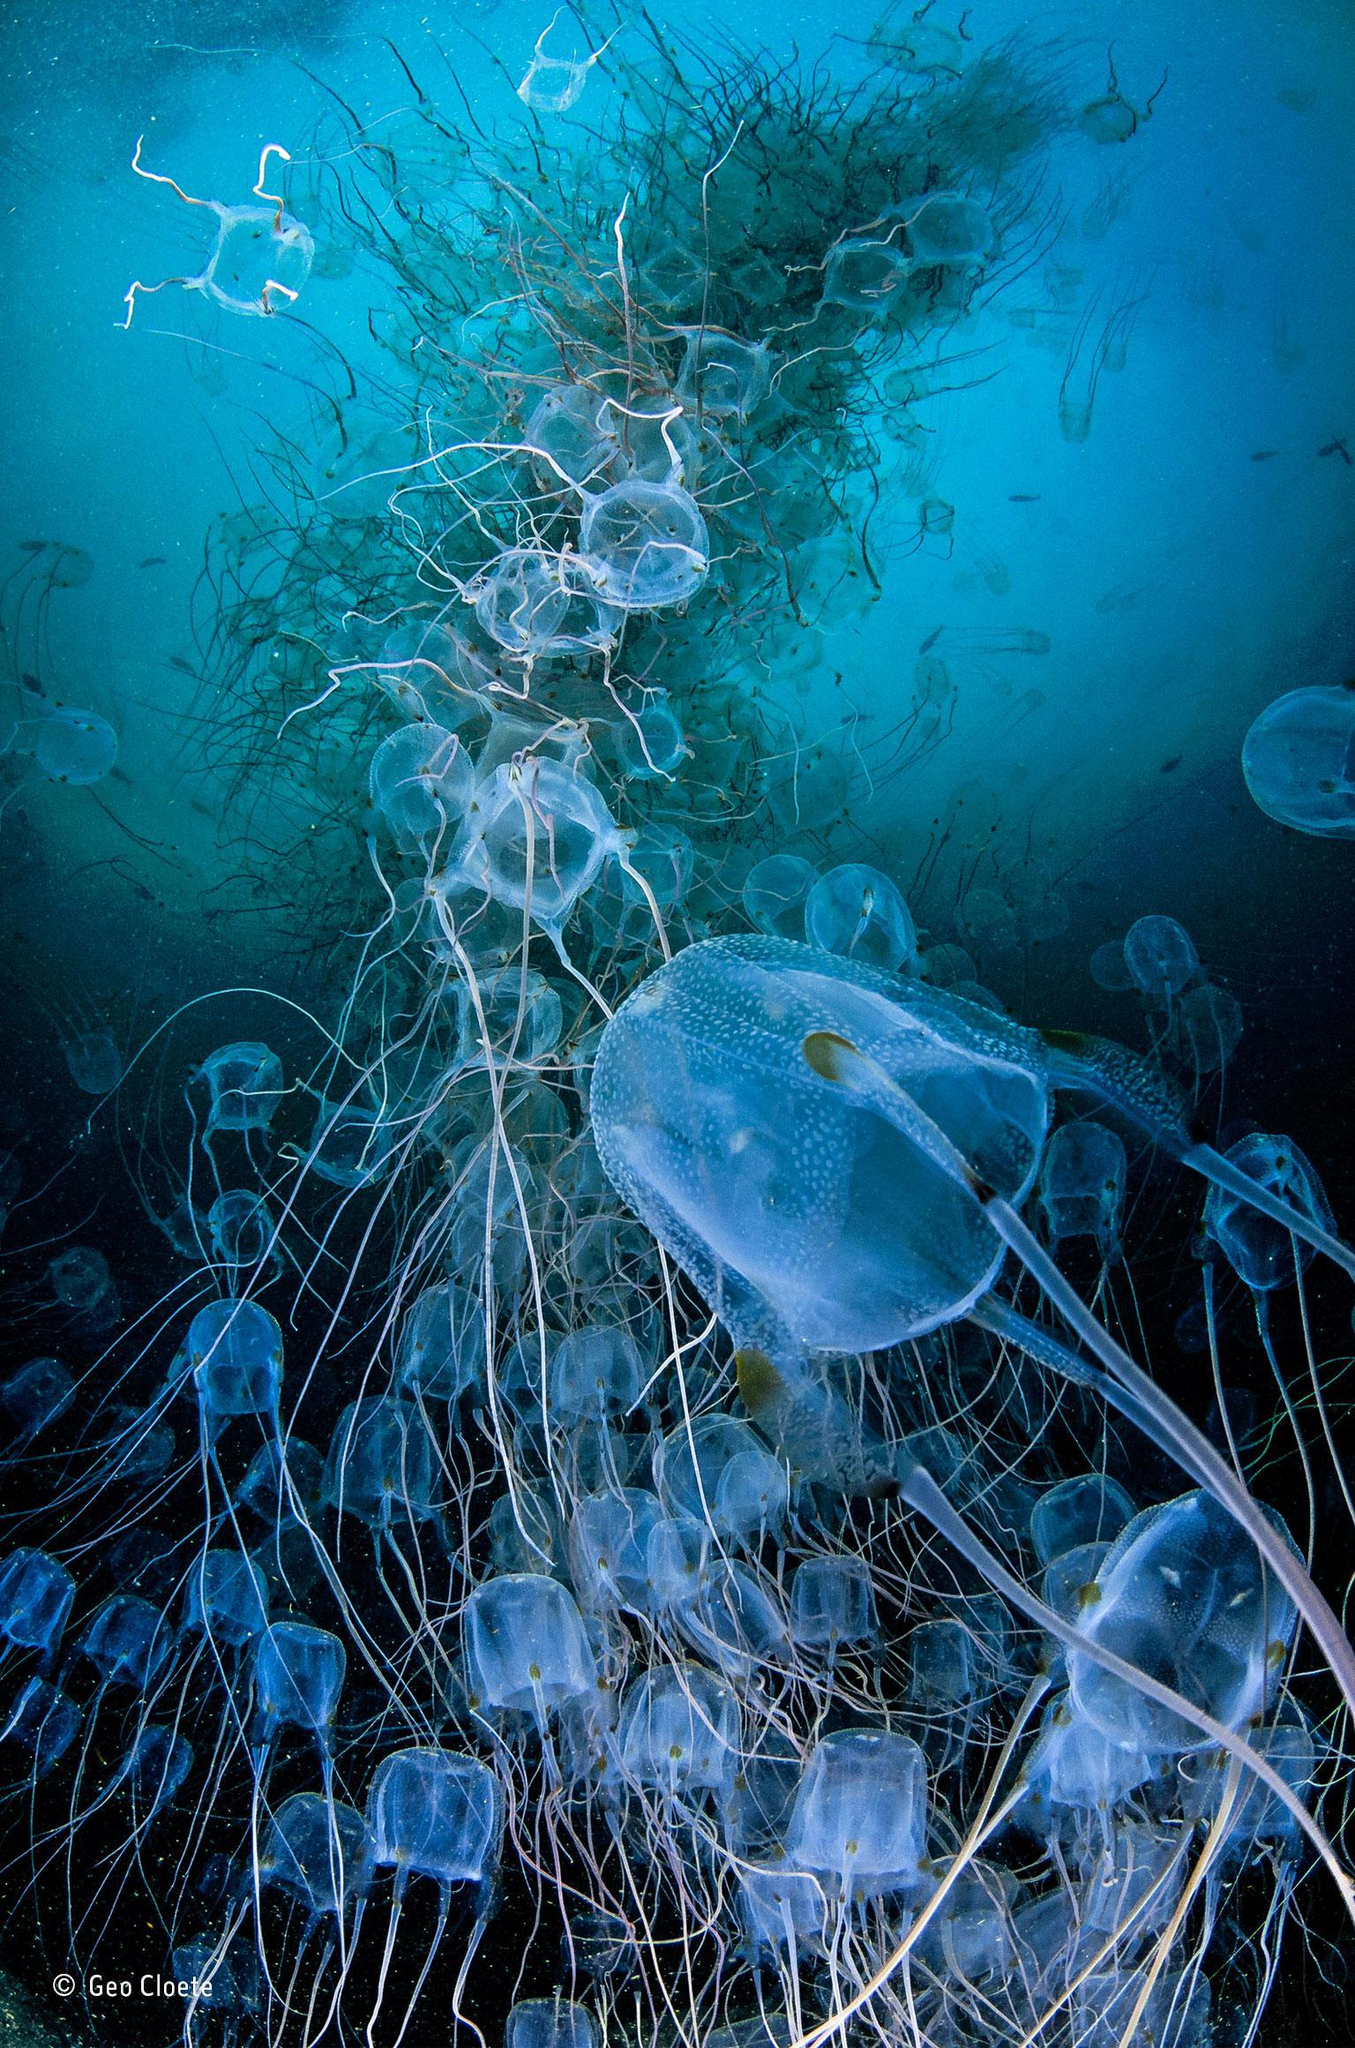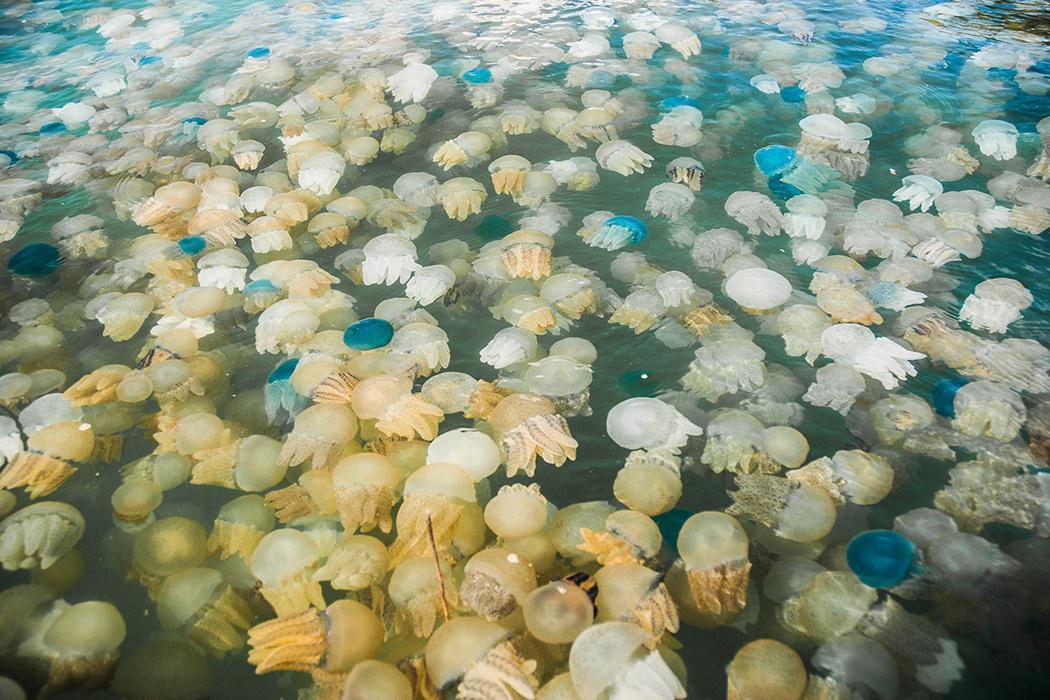The first image is the image on the left, the second image is the image on the right. For the images shown, is this caption "One photo shows a large group of yellow-tinted jellyfish." true? Answer yes or no. Yes. 